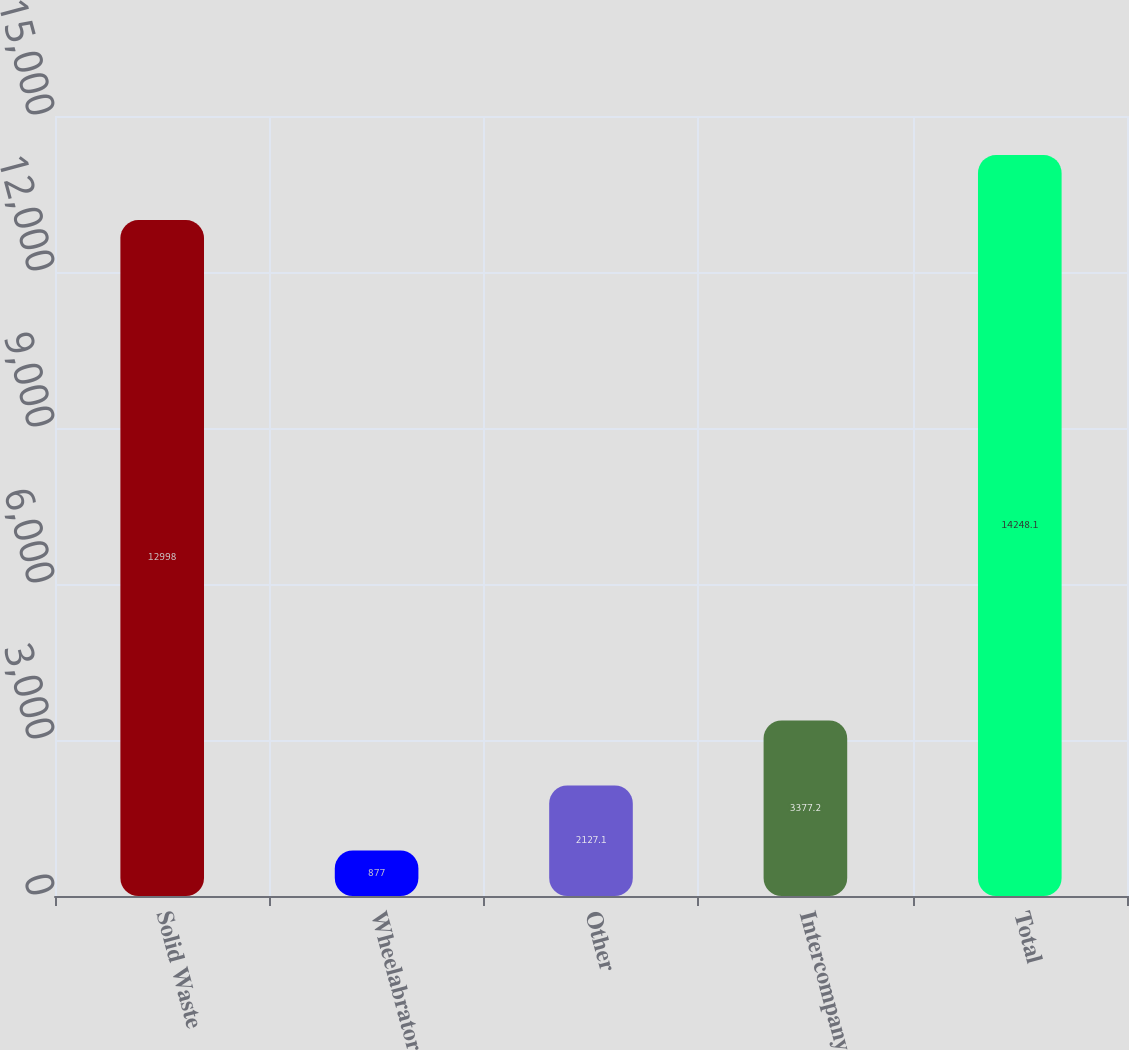<chart> <loc_0><loc_0><loc_500><loc_500><bar_chart><fcel>Solid Waste<fcel>Wheelabrator<fcel>Other<fcel>Intercompany<fcel>Total<nl><fcel>12998<fcel>877<fcel>2127.1<fcel>3377.2<fcel>14248.1<nl></chart> 